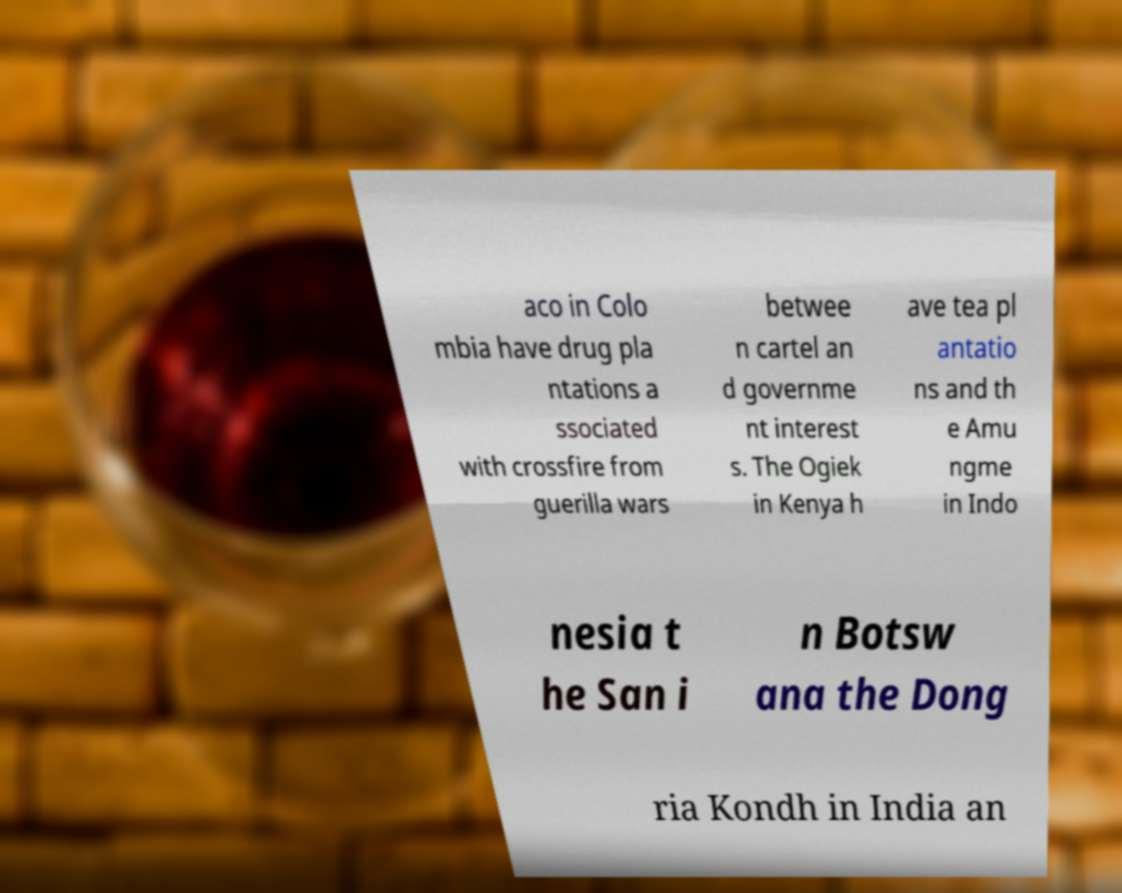There's text embedded in this image that I need extracted. Can you transcribe it verbatim? aco in Colo mbia have drug pla ntations a ssociated with crossfire from guerilla wars betwee n cartel an d governme nt interest s. The Ogiek in Kenya h ave tea pl antatio ns and th e Amu ngme in Indo nesia t he San i n Botsw ana the Dong ria Kondh in India an 